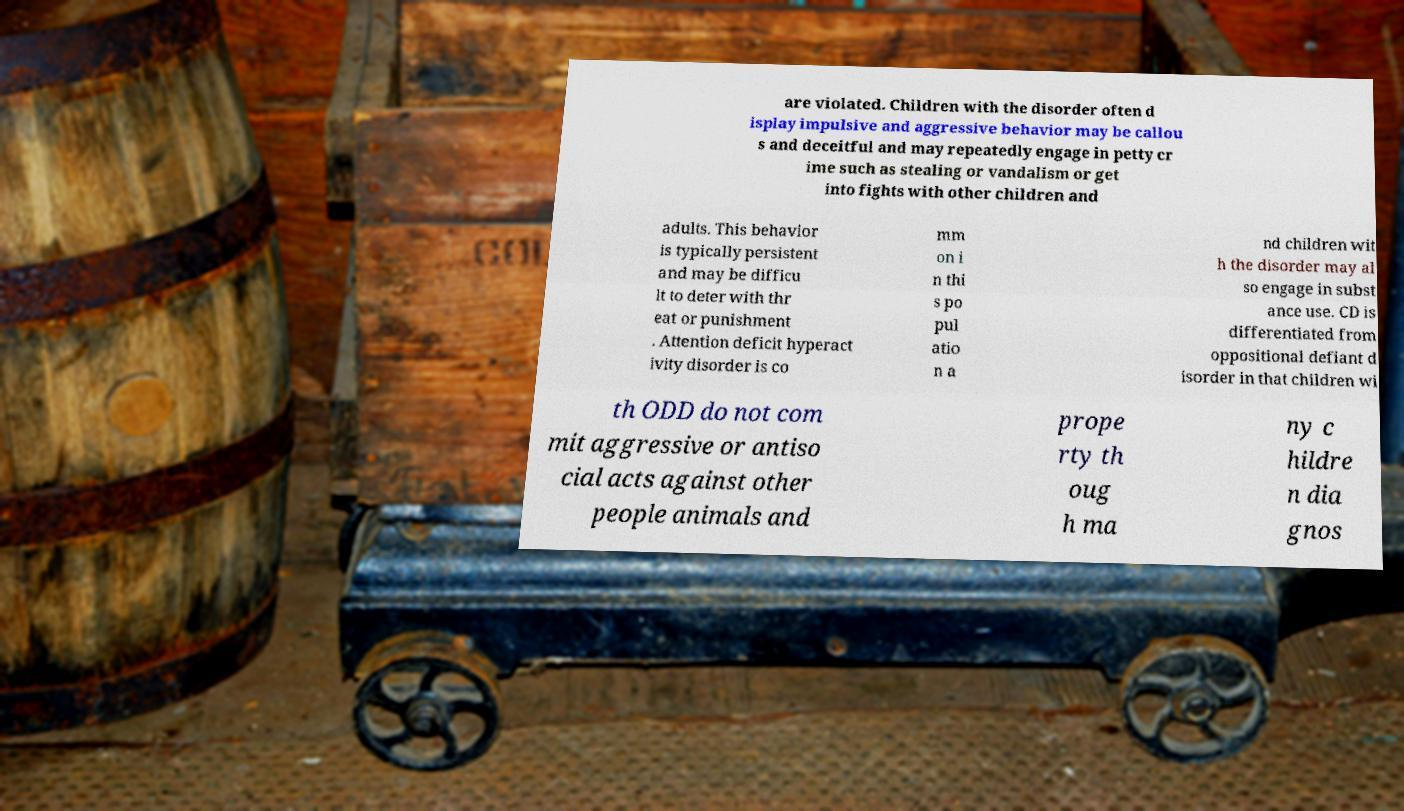Could you extract and type out the text from this image? are violated. Children with the disorder often d isplay impulsive and aggressive behavior may be callou s and deceitful and may repeatedly engage in petty cr ime such as stealing or vandalism or get into fights with other children and adults. This behavior is typically persistent and may be difficu lt to deter with thr eat or punishment . Attention deficit hyperact ivity disorder is co mm on i n thi s po pul atio n a nd children wit h the disorder may al so engage in subst ance use. CD is differentiated from oppositional defiant d isorder in that children wi th ODD do not com mit aggressive or antiso cial acts against other people animals and prope rty th oug h ma ny c hildre n dia gnos 